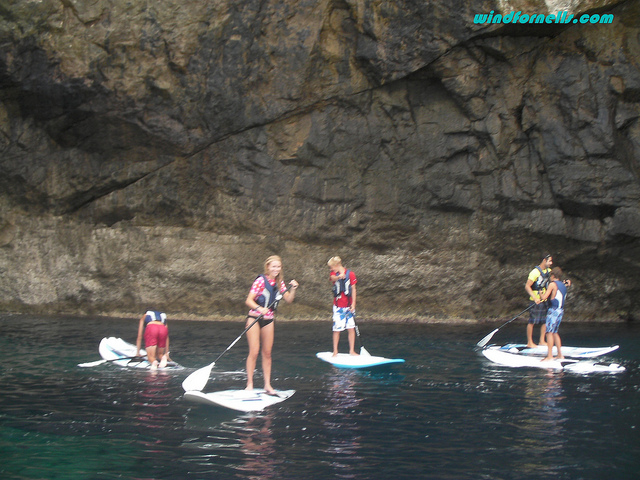Please transcribe the text information in this image. windfornells.com 